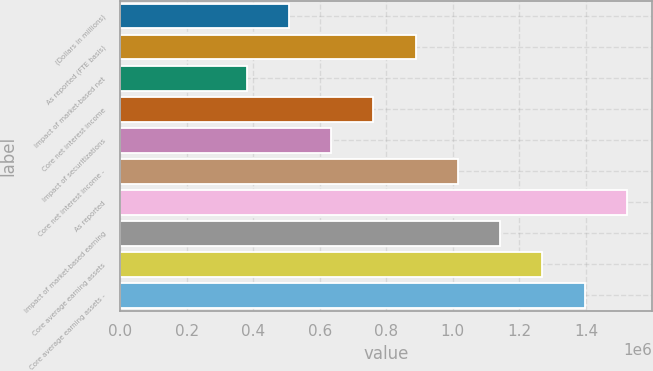<chart> <loc_0><loc_0><loc_500><loc_500><bar_chart><fcel>(Dollars in millions)<fcel>As reported (FTE basis)<fcel>Impact of market-based net<fcel>Core net interest income<fcel>Impact of securitizations<fcel>Core net interest income -<fcel>As reported<fcel>Impact of market-based earning<fcel>Core average earning assets<fcel>Core average earning assets -<nl><fcel>507658<fcel>888401<fcel>380744<fcel>761487<fcel>634572<fcel>1.01532e+06<fcel>1.52297e+06<fcel>1.14223e+06<fcel>1.26914e+06<fcel>1.39606e+06<nl></chart> 